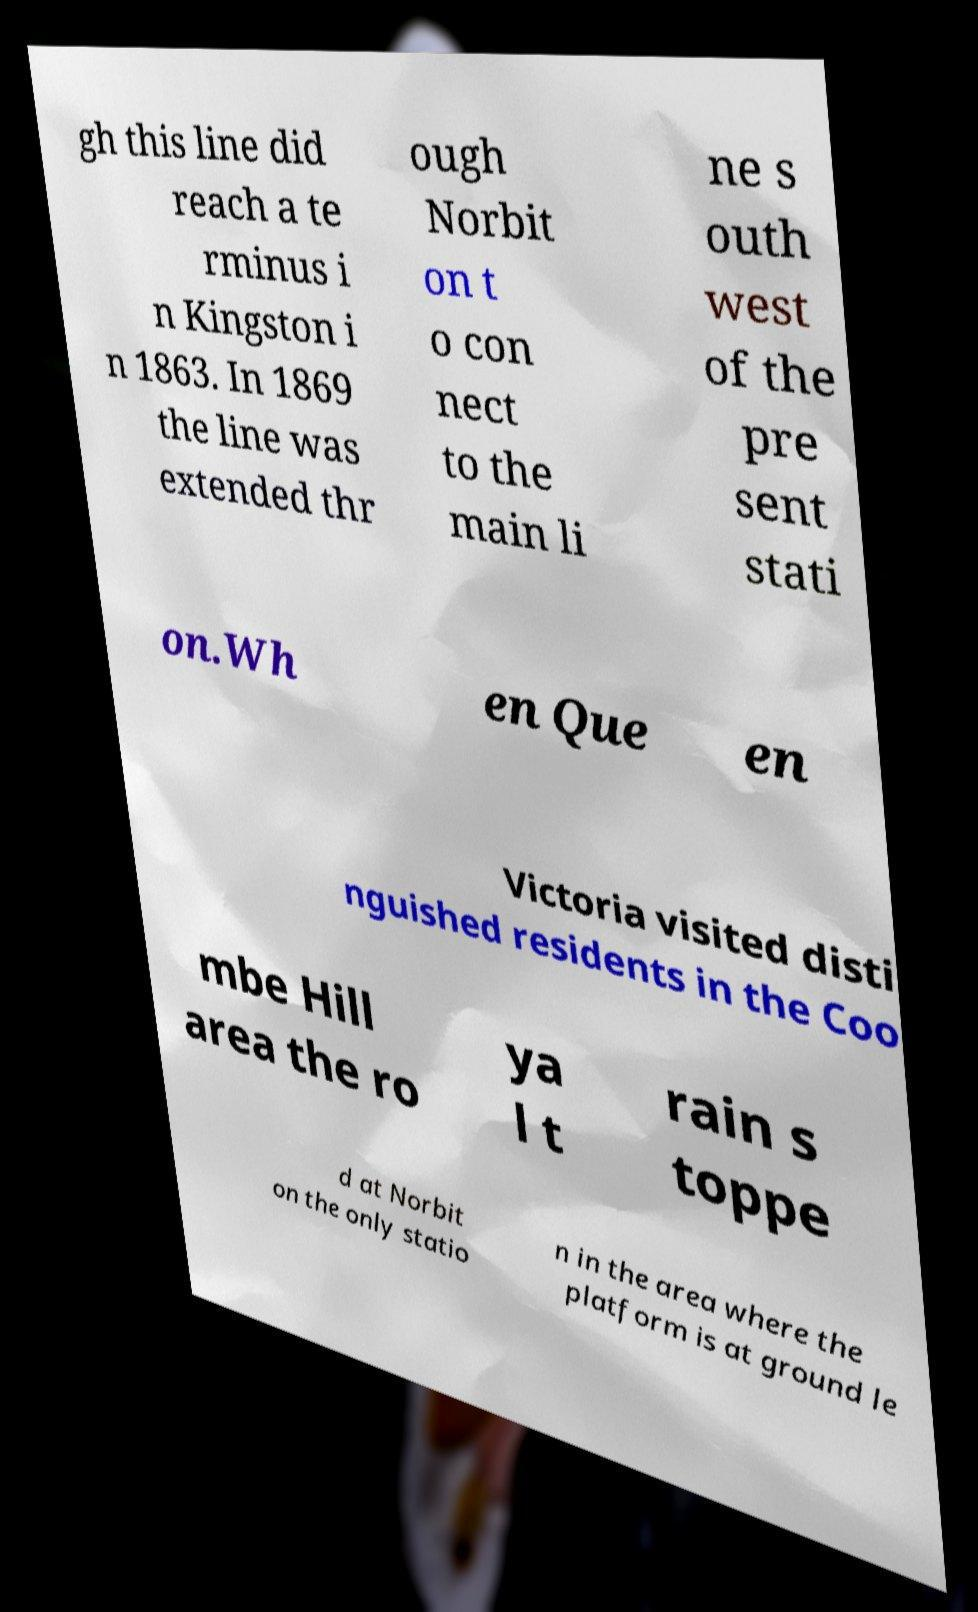Can you accurately transcribe the text from the provided image for me? gh this line did reach a te rminus i n Kingston i n 1863. In 1869 the line was extended thr ough Norbit on t o con nect to the main li ne s outh west of the pre sent stati on.Wh en Que en Victoria visited disti nguished residents in the Coo mbe Hill area the ro ya l t rain s toppe d at Norbit on the only statio n in the area where the platform is at ground le 